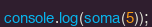<code> <loc_0><loc_0><loc_500><loc_500><_JavaScript_>console.log(soma(5));

</code> 